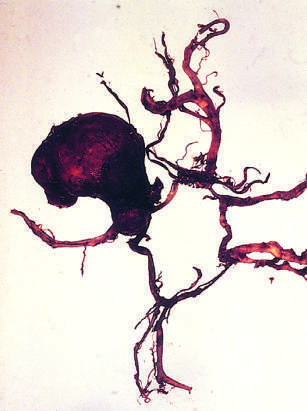what is the circle of willis dissected to?
Answer the question using a single word or phrase. Show a large aneurysm 